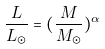Convert formula to latex. <formula><loc_0><loc_0><loc_500><loc_500>\frac { L } { L _ { \odot } } = ( \frac { M } { M _ { \odot } } ) ^ { \alpha }</formula> 